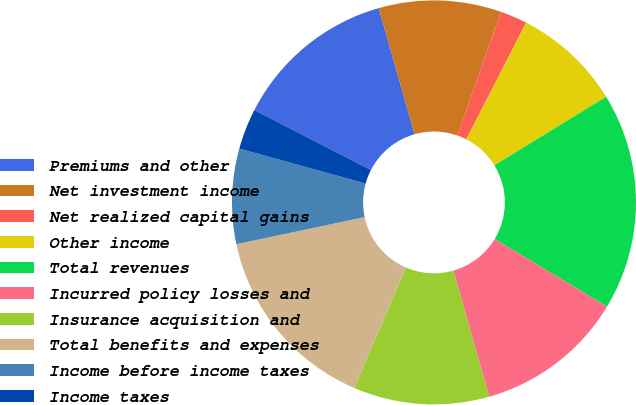Convert chart to OTSL. <chart><loc_0><loc_0><loc_500><loc_500><pie_chart><fcel>Premiums and other<fcel>Net investment income<fcel>Net realized capital gains<fcel>Other income<fcel>Total revenues<fcel>Incurred policy losses and<fcel>Insurance acquisition and<fcel>Total benefits and expenses<fcel>Income before income taxes<fcel>Income taxes<nl><fcel>13.04%<fcel>9.78%<fcel>2.17%<fcel>8.7%<fcel>17.39%<fcel>11.96%<fcel>10.87%<fcel>15.22%<fcel>7.61%<fcel>3.26%<nl></chart> 